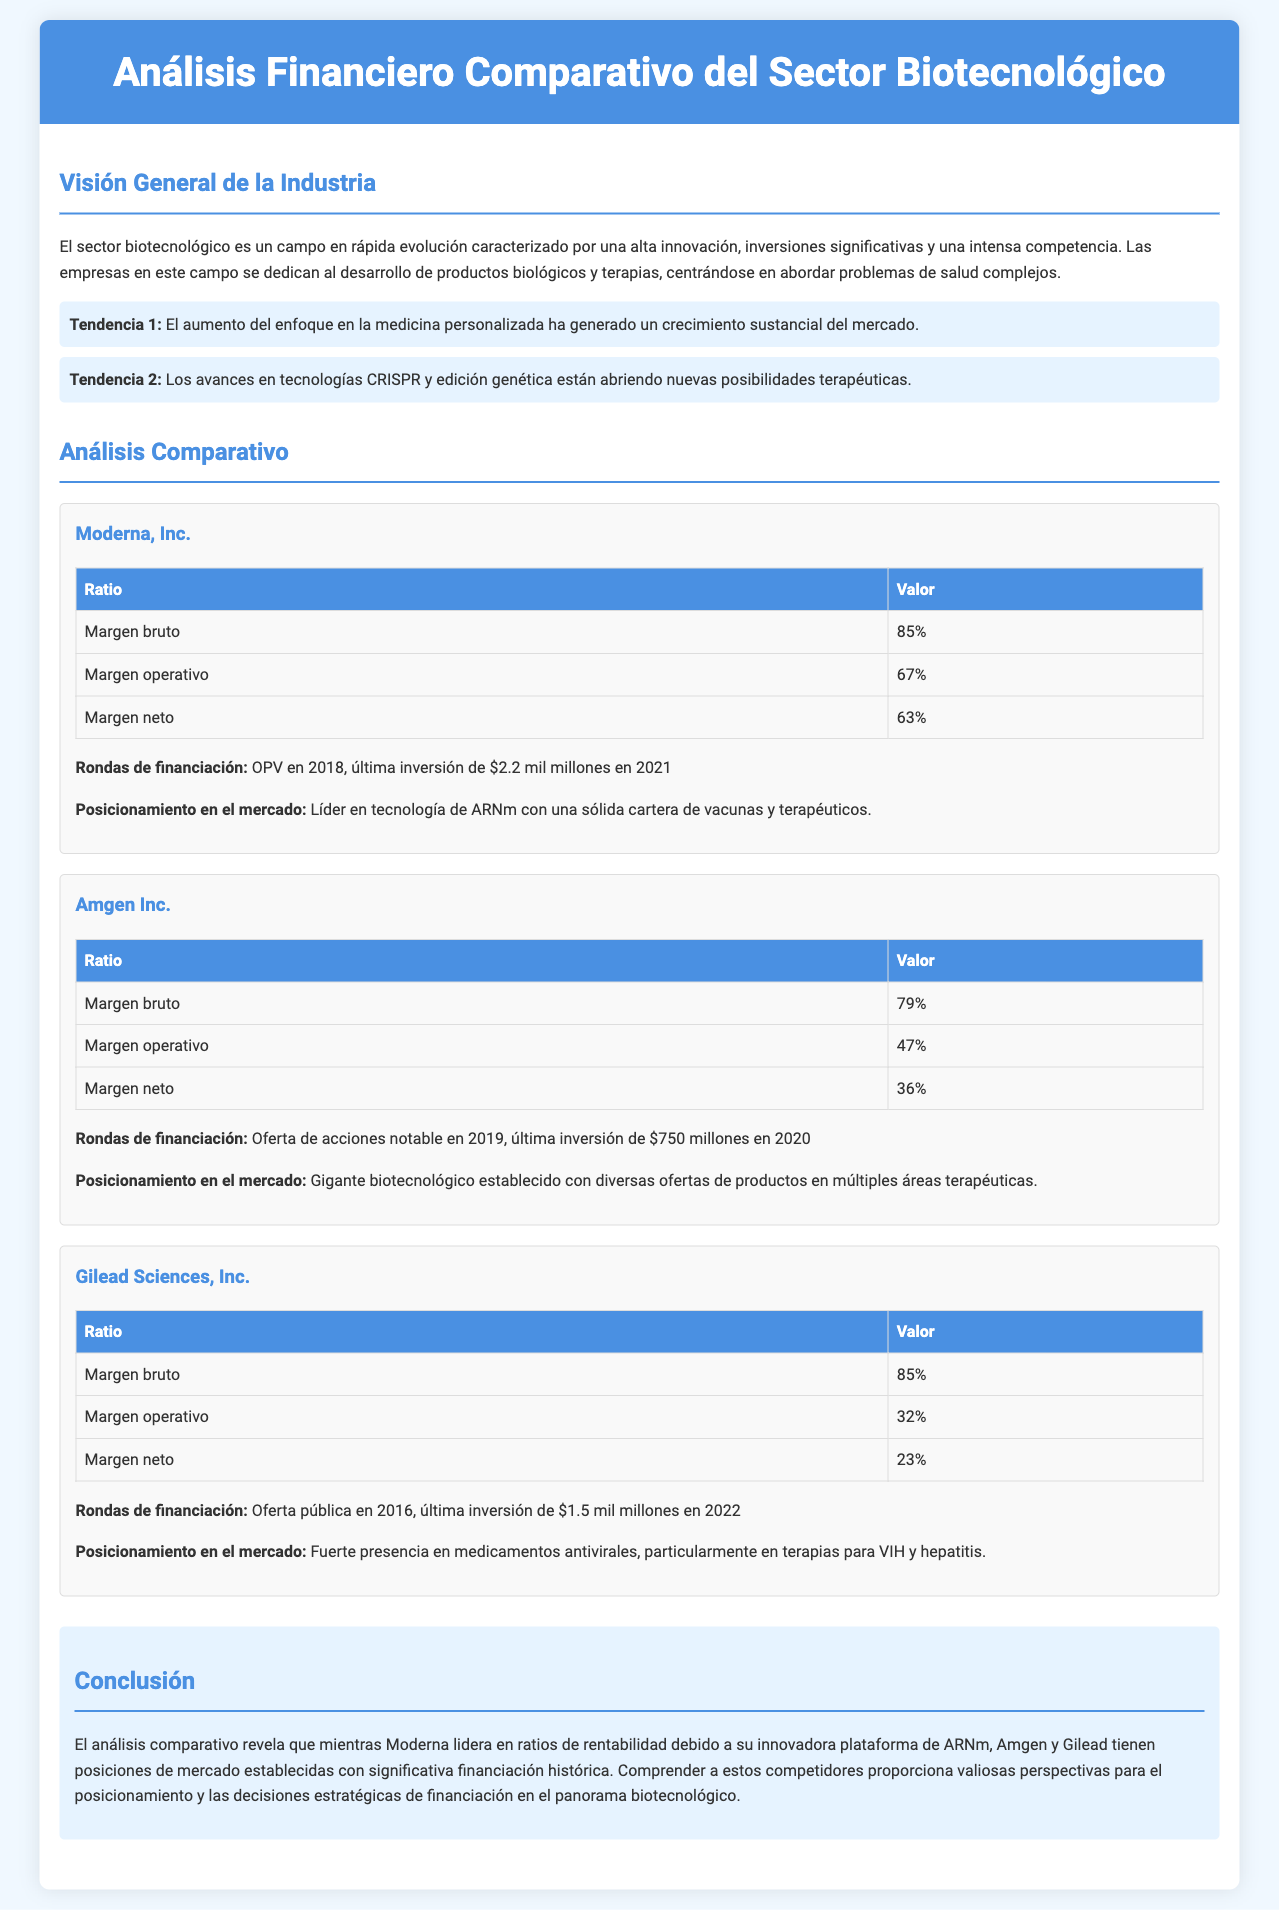¿Cuál es el margen bruto de Moderna, Inc.? El margen bruto de Moderna, Inc. en el documento es un porcentaje que indica su rentabilidad respecto a los ingresos, que es 85%.
Answer: 85% ¿Qué financiación obtuvo Gilead Sciences, Inc. en 2022? La financiación mencionada en el documento para Gilead Sciences, Inc. en 2022 es una última inversión de $1.5 mil millones.
Answer: $1.5 mil millones ¿Cuál es el margen neto de Amgen Inc.? El margen neto es una medida de rentabilidad que se ofrece para Amgen Inc., que se especifica en el documento como 36%.
Answer: 36% ¿Quién lidera en márgenes de rentabilidad según el análisis comparativo? La pregunta se centra en identificar quién tiene mejores márgenes de rentabilidad, y el documento indica que Moderna lidera en ese aspecto.
Answer: Moderna ¿Cuál es el enfoque principal de Gilead Sciences, Inc. en el mercado? Se busca entender la estrategia de mercado de Gilead Sciences, Inc., la cual se menciona en el documento como una fuerte presencia en medicamentos antivirales.
Answer: Medicamentos antivirales ¿Cuál fue la última ronda de financiación para Moderna, Inc.? La última ronda de financiación se describe en el documento como una inversión de $2.2 mil millones en 2021.
Answer: $2.2 mil millones ¿Qué porcentaje de margen operativo tiene Amgen Inc.? Este valor expresa la eficiencia operativa de Amgen Inc. y se indica en el documento como 47%.
Answer: 47% ¿Qué terapias se menciona que Moderna desarrolla? La pregunta busca información sobre el enfoque terapéutico de Moderna, que se menciona como una sólida cartera de vacunas y terapéuticos.
Answer: Vacunas y terapéuticos ¿Qué establece la conclusión acerca de la comparación de Moderna con Amgen y Gilead? La conclusión proporciona una visión general sobre la competencia, señalando que Moderna lidera en rentabilidad y que Amgen y Gilead tienen posiciones establecidas.
Answer: Moderna lidera en rentabilidad 